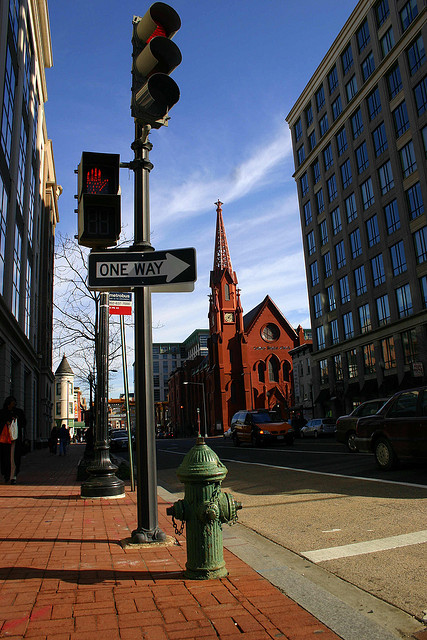What time of day does the lighting in the image suggest? The lighting in the image suggests it is either early morning or late afternoon, as the shadows are long, and the sunlight appears to be coming from a low angle, typical of those times of day. 